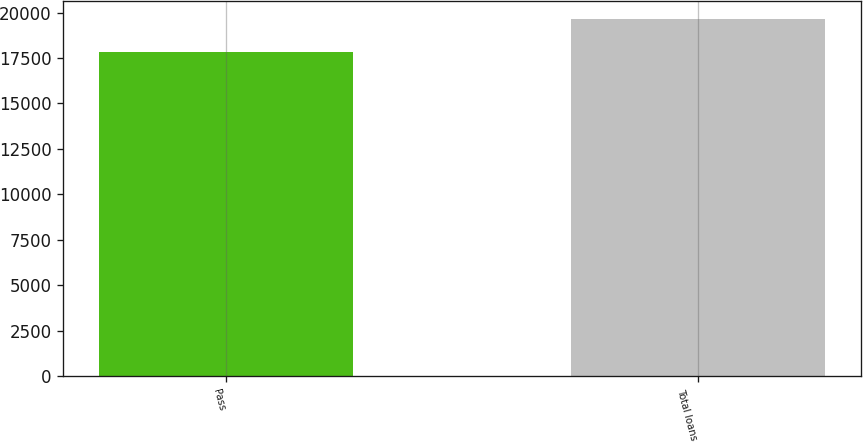Convert chart to OTSL. <chart><loc_0><loc_0><loc_500><loc_500><bar_chart><fcel>Pass<fcel>Total loans<nl><fcel>17847<fcel>19659<nl></chart> 